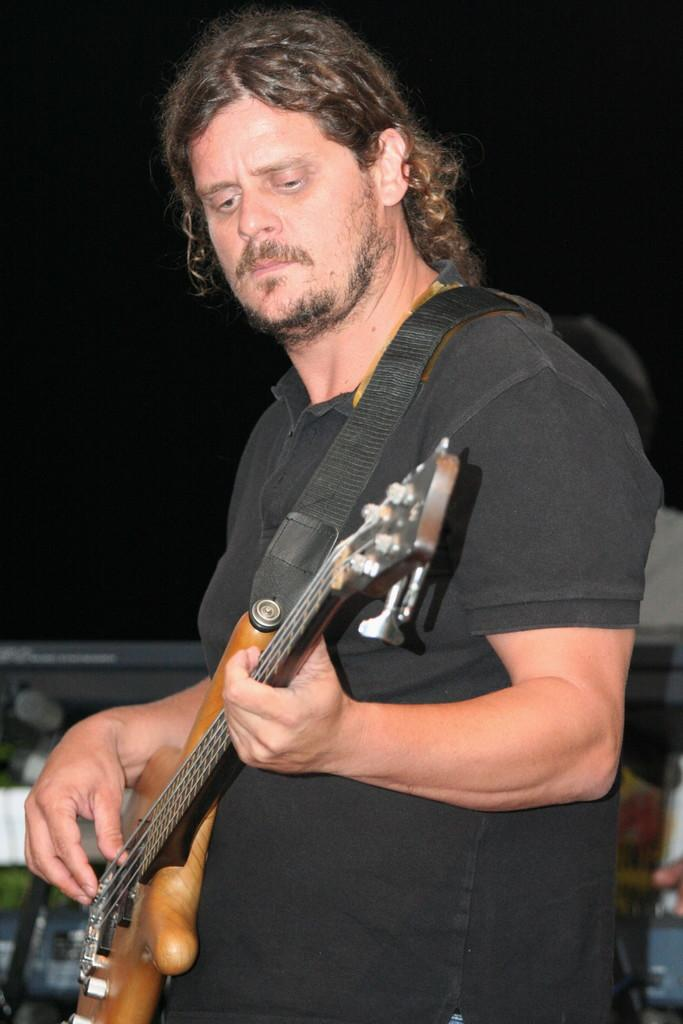What is the main subject of the image? There is a man in the image. What is the man wearing? The man is wearing a black t-shirt. What is the man doing in the image? The man is playing a guitar. What is the man's temper like in the image? There is no information about the man's temper in the image. Can you see a receipt in the image? There is no mention of a receipt in the image. 